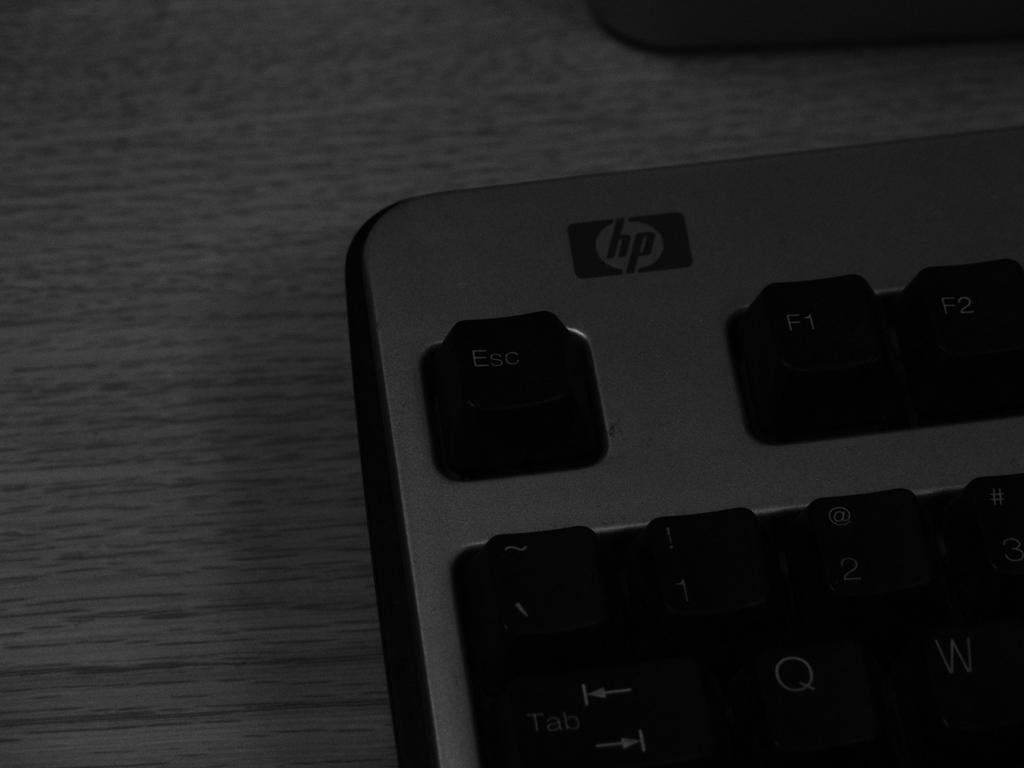<image>
Relay a brief, clear account of the picture shown. A hp keyboard with the escape key in the top left corner. 